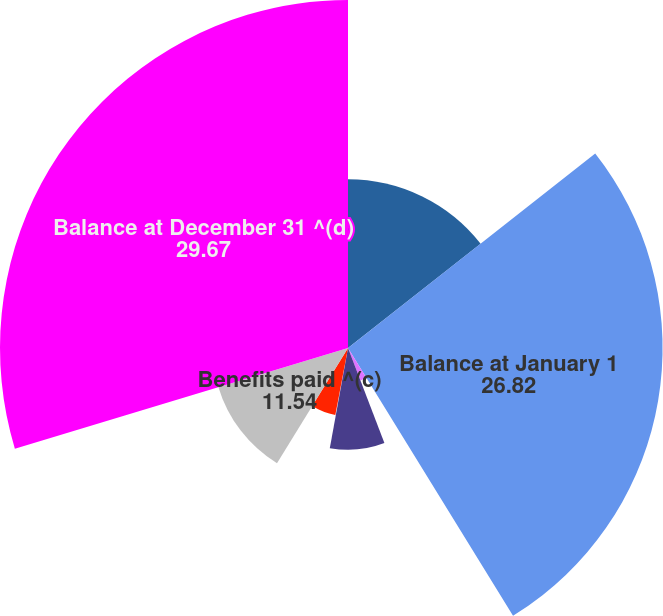Convert chart. <chart><loc_0><loc_0><loc_500><loc_500><pie_chart><fcel>(In millions)<fcel>Balance at January 1<fcel>Service cost for benefits<fcel>Interest cost on benefit<fcel>Participant contributions<fcel>Actuarial loss (gain) ^(a)(b)<fcel>Benefits paid ^(c)<fcel>Balance at December 31 ^(d)<nl><fcel>14.39%<fcel>26.82%<fcel>2.97%<fcel>8.68%<fcel>0.11%<fcel>5.82%<fcel>11.54%<fcel>29.67%<nl></chart> 